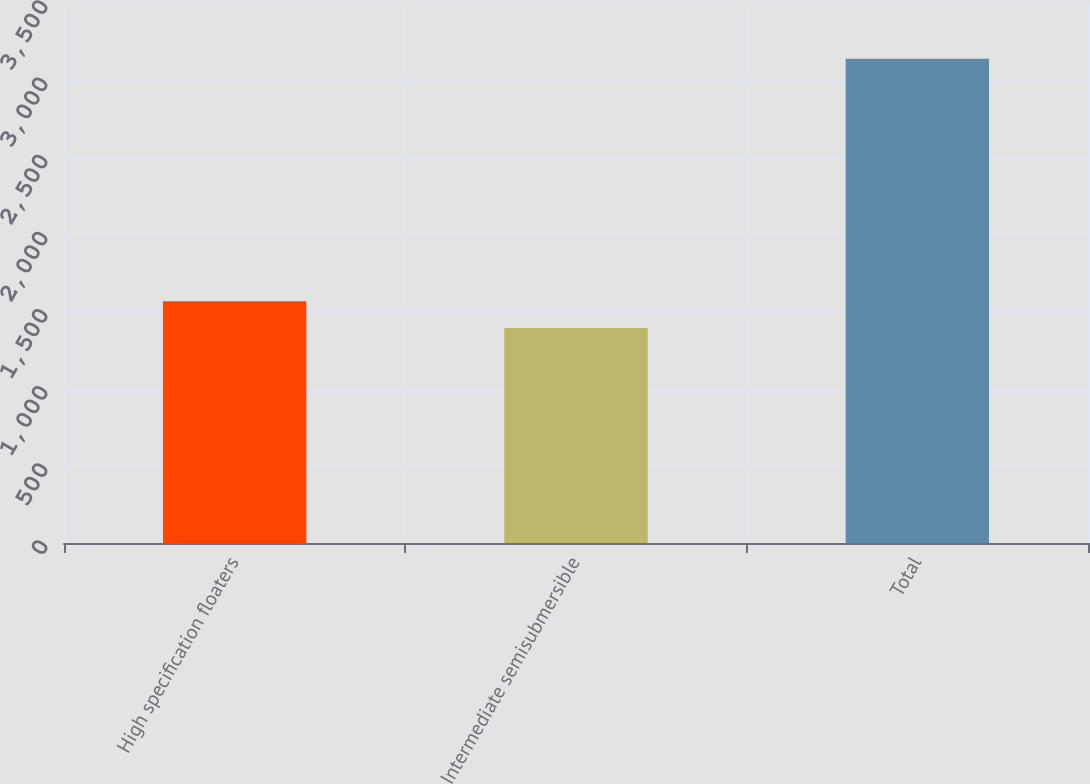Convert chart. <chart><loc_0><loc_0><loc_500><loc_500><bar_chart><fcel>High specification floaters<fcel>Intermediate semisubmersible<fcel>Total<nl><fcel>1567.6<fcel>1393<fcel>3139<nl></chart> 